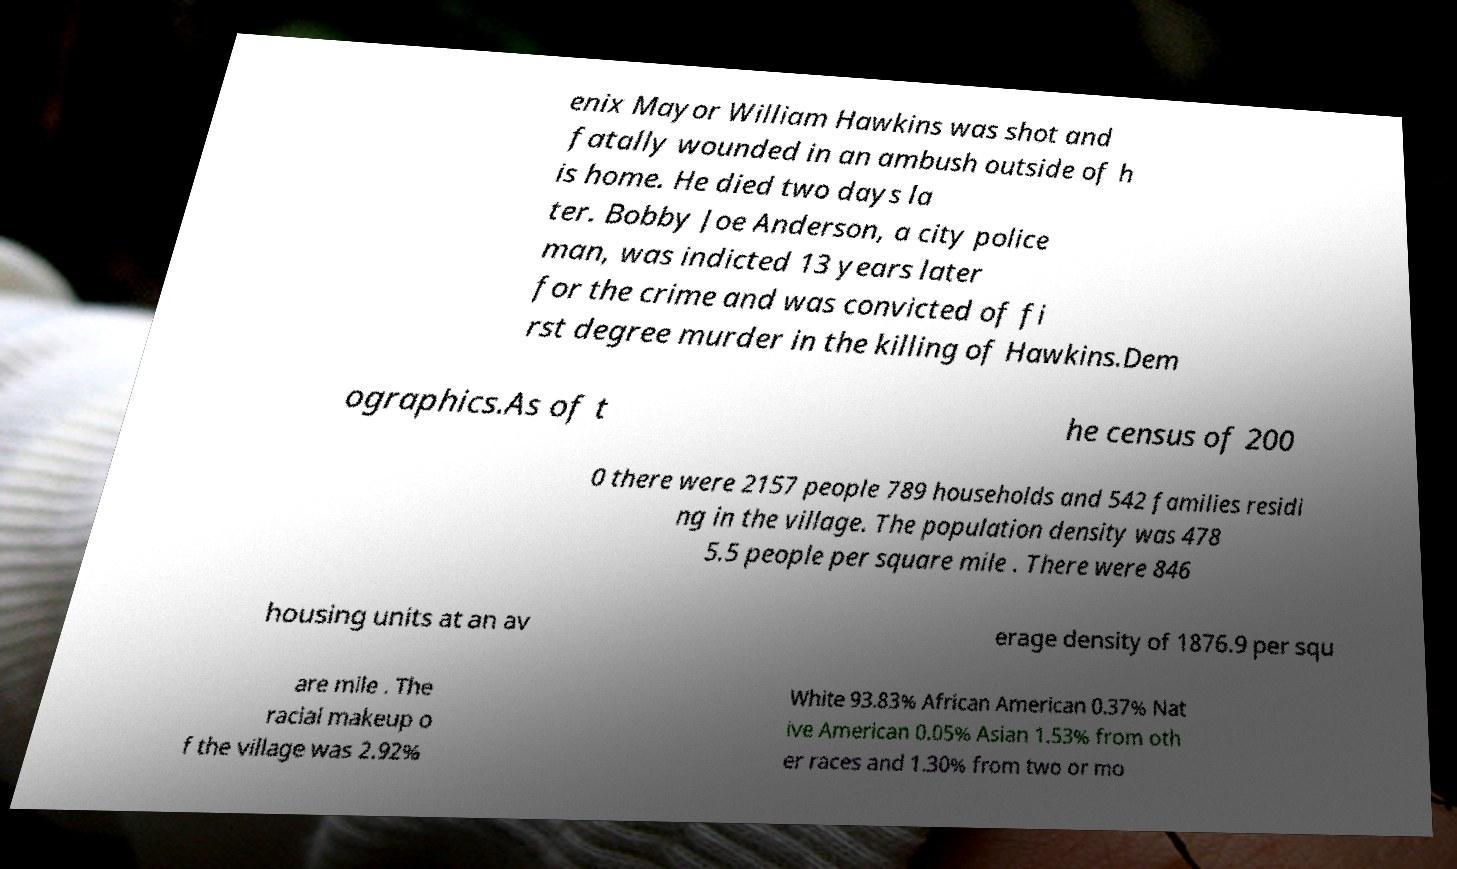Could you assist in decoding the text presented in this image and type it out clearly? enix Mayor William Hawkins was shot and fatally wounded in an ambush outside of h is home. He died two days la ter. Bobby Joe Anderson, a city police man, was indicted 13 years later for the crime and was convicted of fi rst degree murder in the killing of Hawkins.Dem ographics.As of t he census of 200 0 there were 2157 people 789 households and 542 families residi ng in the village. The population density was 478 5.5 people per square mile . There were 846 housing units at an av erage density of 1876.9 per squ are mile . The racial makeup o f the village was 2.92% White 93.83% African American 0.37% Nat ive American 0.05% Asian 1.53% from oth er races and 1.30% from two or mo 